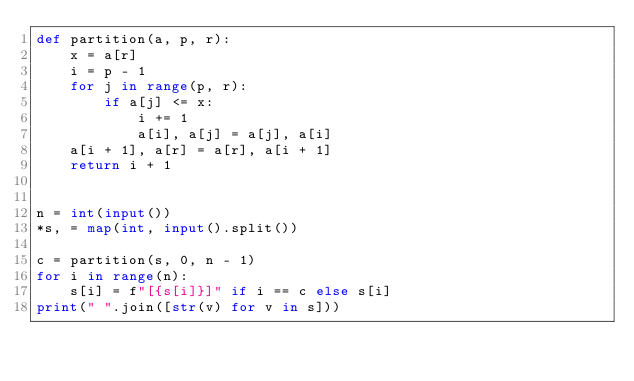Convert code to text. <code><loc_0><loc_0><loc_500><loc_500><_Python_>def partition(a, p, r):
    x = a[r]
    i = p - 1
    for j in range(p, r):
        if a[j] <= x:
            i += 1
            a[i], a[j] = a[j], a[i]
    a[i + 1], a[r] = a[r], a[i + 1]
    return i + 1


n = int(input())
*s, = map(int, input().split())

c = partition(s, 0, n - 1)
for i in range(n):
    s[i] = f"[{s[i]}]" if i == c else s[i]
print(" ".join([str(v) for v in s]))
</code> 